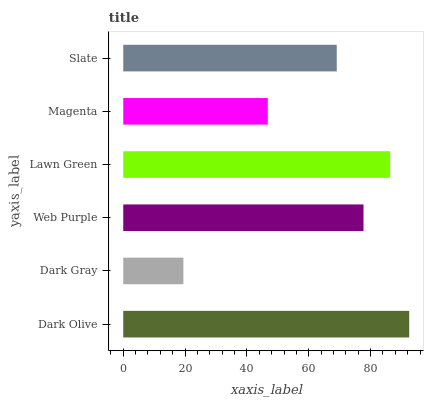Is Dark Gray the minimum?
Answer yes or no. Yes. Is Dark Olive the maximum?
Answer yes or no. Yes. Is Web Purple the minimum?
Answer yes or no. No. Is Web Purple the maximum?
Answer yes or no. No. Is Web Purple greater than Dark Gray?
Answer yes or no. Yes. Is Dark Gray less than Web Purple?
Answer yes or no. Yes. Is Dark Gray greater than Web Purple?
Answer yes or no. No. Is Web Purple less than Dark Gray?
Answer yes or no. No. Is Web Purple the high median?
Answer yes or no. Yes. Is Slate the low median?
Answer yes or no. Yes. Is Lawn Green the high median?
Answer yes or no. No. Is Lawn Green the low median?
Answer yes or no. No. 